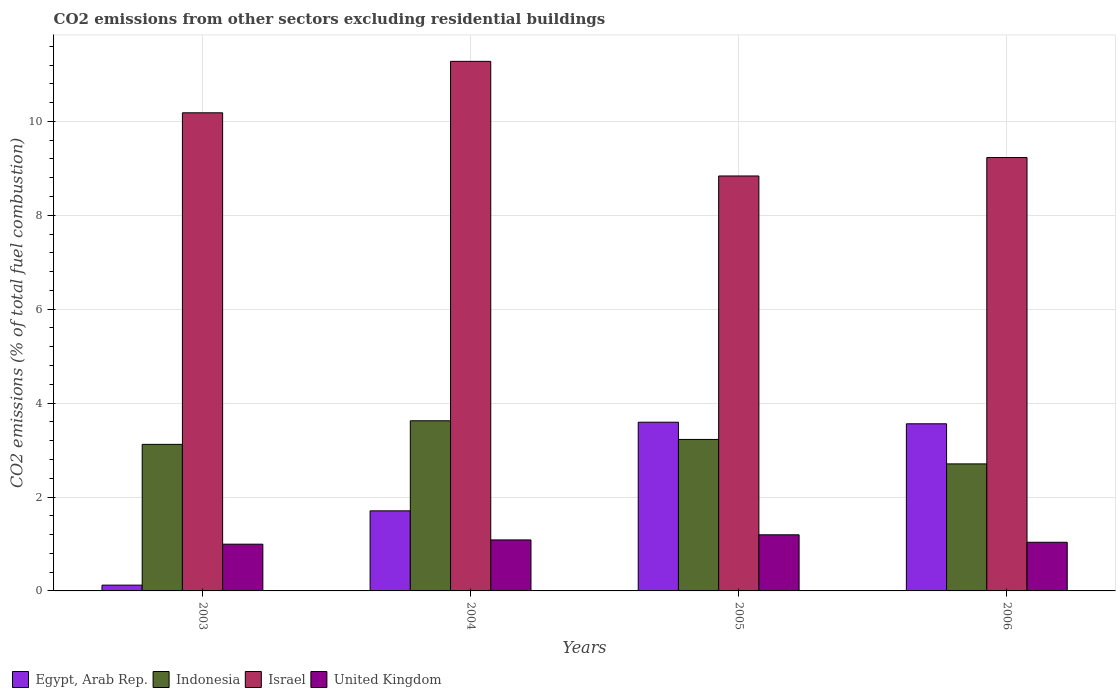How many different coloured bars are there?
Make the answer very short. 4. Are the number of bars per tick equal to the number of legend labels?
Give a very brief answer. Yes. What is the label of the 2nd group of bars from the left?
Your answer should be very brief. 2004. In how many cases, is the number of bars for a given year not equal to the number of legend labels?
Provide a succinct answer. 0. What is the total CO2 emitted in Indonesia in 2005?
Offer a terse response. 3.23. Across all years, what is the maximum total CO2 emitted in United Kingdom?
Your answer should be compact. 1.2. Across all years, what is the minimum total CO2 emitted in United Kingdom?
Your response must be concise. 1. In which year was the total CO2 emitted in Israel maximum?
Your answer should be compact. 2004. What is the total total CO2 emitted in United Kingdom in the graph?
Offer a terse response. 4.31. What is the difference between the total CO2 emitted in Egypt, Arab Rep. in 2004 and that in 2005?
Ensure brevity in your answer.  -1.89. What is the difference between the total CO2 emitted in Indonesia in 2005 and the total CO2 emitted in Egypt, Arab Rep. in 2006?
Keep it short and to the point. -0.33. What is the average total CO2 emitted in Egypt, Arab Rep. per year?
Make the answer very short. 2.25. In the year 2003, what is the difference between the total CO2 emitted in Israel and total CO2 emitted in Indonesia?
Your response must be concise. 7.06. What is the ratio of the total CO2 emitted in United Kingdom in 2005 to that in 2006?
Give a very brief answer. 1.15. Is the difference between the total CO2 emitted in Israel in 2005 and 2006 greater than the difference between the total CO2 emitted in Indonesia in 2005 and 2006?
Your answer should be compact. No. What is the difference between the highest and the second highest total CO2 emitted in Egypt, Arab Rep.?
Your answer should be compact. 0.03. What is the difference between the highest and the lowest total CO2 emitted in Egypt, Arab Rep.?
Offer a very short reply. 3.47. What does the 2nd bar from the right in 2003 represents?
Your response must be concise. Israel. Is it the case that in every year, the sum of the total CO2 emitted in Egypt, Arab Rep. and total CO2 emitted in Indonesia is greater than the total CO2 emitted in United Kingdom?
Your response must be concise. Yes. How many bars are there?
Your answer should be very brief. 16. How many years are there in the graph?
Your response must be concise. 4. Does the graph contain any zero values?
Make the answer very short. No. How are the legend labels stacked?
Provide a short and direct response. Horizontal. What is the title of the graph?
Offer a terse response. CO2 emissions from other sectors excluding residential buildings. What is the label or title of the Y-axis?
Ensure brevity in your answer.  CO2 emissions (% of total fuel combustion). What is the CO2 emissions (% of total fuel combustion) in Egypt, Arab Rep. in 2003?
Provide a succinct answer. 0.12. What is the CO2 emissions (% of total fuel combustion) of Indonesia in 2003?
Keep it short and to the point. 3.12. What is the CO2 emissions (% of total fuel combustion) of Israel in 2003?
Give a very brief answer. 10.18. What is the CO2 emissions (% of total fuel combustion) of United Kingdom in 2003?
Your answer should be very brief. 1. What is the CO2 emissions (% of total fuel combustion) of Egypt, Arab Rep. in 2004?
Offer a very short reply. 1.71. What is the CO2 emissions (% of total fuel combustion) of Indonesia in 2004?
Offer a terse response. 3.62. What is the CO2 emissions (% of total fuel combustion) of Israel in 2004?
Your answer should be compact. 11.28. What is the CO2 emissions (% of total fuel combustion) in United Kingdom in 2004?
Offer a terse response. 1.09. What is the CO2 emissions (% of total fuel combustion) of Egypt, Arab Rep. in 2005?
Offer a terse response. 3.59. What is the CO2 emissions (% of total fuel combustion) of Indonesia in 2005?
Your answer should be very brief. 3.23. What is the CO2 emissions (% of total fuel combustion) in Israel in 2005?
Ensure brevity in your answer.  8.84. What is the CO2 emissions (% of total fuel combustion) of United Kingdom in 2005?
Your answer should be very brief. 1.2. What is the CO2 emissions (% of total fuel combustion) of Egypt, Arab Rep. in 2006?
Ensure brevity in your answer.  3.56. What is the CO2 emissions (% of total fuel combustion) of Indonesia in 2006?
Your answer should be very brief. 2.71. What is the CO2 emissions (% of total fuel combustion) of Israel in 2006?
Offer a terse response. 9.23. What is the CO2 emissions (% of total fuel combustion) in United Kingdom in 2006?
Give a very brief answer. 1.04. Across all years, what is the maximum CO2 emissions (% of total fuel combustion) in Egypt, Arab Rep.?
Your answer should be very brief. 3.59. Across all years, what is the maximum CO2 emissions (% of total fuel combustion) of Indonesia?
Offer a very short reply. 3.62. Across all years, what is the maximum CO2 emissions (% of total fuel combustion) in Israel?
Provide a succinct answer. 11.28. Across all years, what is the maximum CO2 emissions (% of total fuel combustion) of United Kingdom?
Your answer should be compact. 1.2. Across all years, what is the minimum CO2 emissions (% of total fuel combustion) in Egypt, Arab Rep.?
Your answer should be compact. 0.12. Across all years, what is the minimum CO2 emissions (% of total fuel combustion) in Indonesia?
Give a very brief answer. 2.71. Across all years, what is the minimum CO2 emissions (% of total fuel combustion) in Israel?
Keep it short and to the point. 8.84. Across all years, what is the minimum CO2 emissions (% of total fuel combustion) in United Kingdom?
Provide a short and direct response. 1. What is the total CO2 emissions (% of total fuel combustion) of Egypt, Arab Rep. in the graph?
Keep it short and to the point. 8.98. What is the total CO2 emissions (% of total fuel combustion) in Indonesia in the graph?
Your answer should be very brief. 12.68. What is the total CO2 emissions (% of total fuel combustion) in Israel in the graph?
Your answer should be compact. 39.53. What is the total CO2 emissions (% of total fuel combustion) in United Kingdom in the graph?
Your answer should be very brief. 4.31. What is the difference between the CO2 emissions (% of total fuel combustion) in Egypt, Arab Rep. in 2003 and that in 2004?
Make the answer very short. -1.58. What is the difference between the CO2 emissions (% of total fuel combustion) in Indonesia in 2003 and that in 2004?
Keep it short and to the point. -0.5. What is the difference between the CO2 emissions (% of total fuel combustion) in Israel in 2003 and that in 2004?
Offer a terse response. -1.1. What is the difference between the CO2 emissions (% of total fuel combustion) in United Kingdom in 2003 and that in 2004?
Keep it short and to the point. -0.09. What is the difference between the CO2 emissions (% of total fuel combustion) of Egypt, Arab Rep. in 2003 and that in 2005?
Ensure brevity in your answer.  -3.47. What is the difference between the CO2 emissions (% of total fuel combustion) of Indonesia in 2003 and that in 2005?
Provide a succinct answer. -0.1. What is the difference between the CO2 emissions (% of total fuel combustion) of Israel in 2003 and that in 2005?
Make the answer very short. 1.35. What is the difference between the CO2 emissions (% of total fuel combustion) in United Kingdom in 2003 and that in 2005?
Offer a very short reply. -0.2. What is the difference between the CO2 emissions (% of total fuel combustion) of Egypt, Arab Rep. in 2003 and that in 2006?
Provide a short and direct response. -3.44. What is the difference between the CO2 emissions (% of total fuel combustion) of Indonesia in 2003 and that in 2006?
Ensure brevity in your answer.  0.42. What is the difference between the CO2 emissions (% of total fuel combustion) in Israel in 2003 and that in 2006?
Provide a succinct answer. 0.95. What is the difference between the CO2 emissions (% of total fuel combustion) of United Kingdom in 2003 and that in 2006?
Your answer should be very brief. -0.04. What is the difference between the CO2 emissions (% of total fuel combustion) of Egypt, Arab Rep. in 2004 and that in 2005?
Make the answer very short. -1.89. What is the difference between the CO2 emissions (% of total fuel combustion) in Indonesia in 2004 and that in 2005?
Keep it short and to the point. 0.4. What is the difference between the CO2 emissions (% of total fuel combustion) of Israel in 2004 and that in 2005?
Keep it short and to the point. 2.44. What is the difference between the CO2 emissions (% of total fuel combustion) in United Kingdom in 2004 and that in 2005?
Your response must be concise. -0.11. What is the difference between the CO2 emissions (% of total fuel combustion) in Egypt, Arab Rep. in 2004 and that in 2006?
Give a very brief answer. -1.85. What is the difference between the CO2 emissions (% of total fuel combustion) of Indonesia in 2004 and that in 2006?
Your answer should be compact. 0.92. What is the difference between the CO2 emissions (% of total fuel combustion) in Israel in 2004 and that in 2006?
Your answer should be compact. 2.05. What is the difference between the CO2 emissions (% of total fuel combustion) of United Kingdom in 2004 and that in 2006?
Make the answer very short. 0.05. What is the difference between the CO2 emissions (% of total fuel combustion) of Egypt, Arab Rep. in 2005 and that in 2006?
Your answer should be compact. 0.03. What is the difference between the CO2 emissions (% of total fuel combustion) of Indonesia in 2005 and that in 2006?
Keep it short and to the point. 0.52. What is the difference between the CO2 emissions (% of total fuel combustion) of Israel in 2005 and that in 2006?
Provide a succinct answer. -0.39. What is the difference between the CO2 emissions (% of total fuel combustion) in United Kingdom in 2005 and that in 2006?
Provide a succinct answer. 0.16. What is the difference between the CO2 emissions (% of total fuel combustion) of Egypt, Arab Rep. in 2003 and the CO2 emissions (% of total fuel combustion) of Indonesia in 2004?
Keep it short and to the point. -3.5. What is the difference between the CO2 emissions (% of total fuel combustion) in Egypt, Arab Rep. in 2003 and the CO2 emissions (% of total fuel combustion) in Israel in 2004?
Give a very brief answer. -11.16. What is the difference between the CO2 emissions (% of total fuel combustion) of Egypt, Arab Rep. in 2003 and the CO2 emissions (% of total fuel combustion) of United Kingdom in 2004?
Offer a terse response. -0.96. What is the difference between the CO2 emissions (% of total fuel combustion) of Indonesia in 2003 and the CO2 emissions (% of total fuel combustion) of Israel in 2004?
Ensure brevity in your answer.  -8.16. What is the difference between the CO2 emissions (% of total fuel combustion) in Indonesia in 2003 and the CO2 emissions (% of total fuel combustion) in United Kingdom in 2004?
Provide a short and direct response. 2.04. What is the difference between the CO2 emissions (% of total fuel combustion) in Israel in 2003 and the CO2 emissions (% of total fuel combustion) in United Kingdom in 2004?
Make the answer very short. 9.1. What is the difference between the CO2 emissions (% of total fuel combustion) of Egypt, Arab Rep. in 2003 and the CO2 emissions (% of total fuel combustion) of Indonesia in 2005?
Your answer should be compact. -3.1. What is the difference between the CO2 emissions (% of total fuel combustion) of Egypt, Arab Rep. in 2003 and the CO2 emissions (% of total fuel combustion) of Israel in 2005?
Provide a short and direct response. -8.71. What is the difference between the CO2 emissions (% of total fuel combustion) in Egypt, Arab Rep. in 2003 and the CO2 emissions (% of total fuel combustion) in United Kingdom in 2005?
Your answer should be compact. -1.07. What is the difference between the CO2 emissions (% of total fuel combustion) of Indonesia in 2003 and the CO2 emissions (% of total fuel combustion) of Israel in 2005?
Ensure brevity in your answer.  -5.72. What is the difference between the CO2 emissions (% of total fuel combustion) in Indonesia in 2003 and the CO2 emissions (% of total fuel combustion) in United Kingdom in 2005?
Offer a terse response. 1.93. What is the difference between the CO2 emissions (% of total fuel combustion) in Israel in 2003 and the CO2 emissions (% of total fuel combustion) in United Kingdom in 2005?
Ensure brevity in your answer.  8.99. What is the difference between the CO2 emissions (% of total fuel combustion) of Egypt, Arab Rep. in 2003 and the CO2 emissions (% of total fuel combustion) of Indonesia in 2006?
Offer a very short reply. -2.58. What is the difference between the CO2 emissions (% of total fuel combustion) in Egypt, Arab Rep. in 2003 and the CO2 emissions (% of total fuel combustion) in Israel in 2006?
Make the answer very short. -9.11. What is the difference between the CO2 emissions (% of total fuel combustion) of Egypt, Arab Rep. in 2003 and the CO2 emissions (% of total fuel combustion) of United Kingdom in 2006?
Provide a succinct answer. -0.91. What is the difference between the CO2 emissions (% of total fuel combustion) in Indonesia in 2003 and the CO2 emissions (% of total fuel combustion) in Israel in 2006?
Provide a short and direct response. -6.11. What is the difference between the CO2 emissions (% of total fuel combustion) of Indonesia in 2003 and the CO2 emissions (% of total fuel combustion) of United Kingdom in 2006?
Give a very brief answer. 2.09. What is the difference between the CO2 emissions (% of total fuel combustion) of Israel in 2003 and the CO2 emissions (% of total fuel combustion) of United Kingdom in 2006?
Your answer should be compact. 9.15. What is the difference between the CO2 emissions (% of total fuel combustion) in Egypt, Arab Rep. in 2004 and the CO2 emissions (% of total fuel combustion) in Indonesia in 2005?
Your answer should be very brief. -1.52. What is the difference between the CO2 emissions (% of total fuel combustion) of Egypt, Arab Rep. in 2004 and the CO2 emissions (% of total fuel combustion) of Israel in 2005?
Provide a succinct answer. -7.13. What is the difference between the CO2 emissions (% of total fuel combustion) in Egypt, Arab Rep. in 2004 and the CO2 emissions (% of total fuel combustion) in United Kingdom in 2005?
Ensure brevity in your answer.  0.51. What is the difference between the CO2 emissions (% of total fuel combustion) in Indonesia in 2004 and the CO2 emissions (% of total fuel combustion) in Israel in 2005?
Offer a very short reply. -5.21. What is the difference between the CO2 emissions (% of total fuel combustion) of Indonesia in 2004 and the CO2 emissions (% of total fuel combustion) of United Kingdom in 2005?
Provide a short and direct response. 2.43. What is the difference between the CO2 emissions (% of total fuel combustion) of Israel in 2004 and the CO2 emissions (% of total fuel combustion) of United Kingdom in 2005?
Give a very brief answer. 10.08. What is the difference between the CO2 emissions (% of total fuel combustion) in Egypt, Arab Rep. in 2004 and the CO2 emissions (% of total fuel combustion) in Indonesia in 2006?
Your response must be concise. -1. What is the difference between the CO2 emissions (% of total fuel combustion) of Egypt, Arab Rep. in 2004 and the CO2 emissions (% of total fuel combustion) of Israel in 2006?
Keep it short and to the point. -7.52. What is the difference between the CO2 emissions (% of total fuel combustion) of Egypt, Arab Rep. in 2004 and the CO2 emissions (% of total fuel combustion) of United Kingdom in 2006?
Offer a terse response. 0.67. What is the difference between the CO2 emissions (% of total fuel combustion) in Indonesia in 2004 and the CO2 emissions (% of total fuel combustion) in Israel in 2006?
Keep it short and to the point. -5.61. What is the difference between the CO2 emissions (% of total fuel combustion) of Indonesia in 2004 and the CO2 emissions (% of total fuel combustion) of United Kingdom in 2006?
Offer a very short reply. 2.59. What is the difference between the CO2 emissions (% of total fuel combustion) in Israel in 2004 and the CO2 emissions (% of total fuel combustion) in United Kingdom in 2006?
Make the answer very short. 10.24. What is the difference between the CO2 emissions (% of total fuel combustion) in Egypt, Arab Rep. in 2005 and the CO2 emissions (% of total fuel combustion) in Indonesia in 2006?
Ensure brevity in your answer.  0.89. What is the difference between the CO2 emissions (% of total fuel combustion) of Egypt, Arab Rep. in 2005 and the CO2 emissions (% of total fuel combustion) of Israel in 2006?
Your answer should be compact. -5.64. What is the difference between the CO2 emissions (% of total fuel combustion) in Egypt, Arab Rep. in 2005 and the CO2 emissions (% of total fuel combustion) in United Kingdom in 2006?
Provide a short and direct response. 2.56. What is the difference between the CO2 emissions (% of total fuel combustion) of Indonesia in 2005 and the CO2 emissions (% of total fuel combustion) of Israel in 2006?
Give a very brief answer. -6. What is the difference between the CO2 emissions (% of total fuel combustion) in Indonesia in 2005 and the CO2 emissions (% of total fuel combustion) in United Kingdom in 2006?
Your answer should be very brief. 2.19. What is the difference between the CO2 emissions (% of total fuel combustion) in Israel in 2005 and the CO2 emissions (% of total fuel combustion) in United Kingdom in 2006?
Provide a short and direct response. 7.8. What is the average CO2 emissions (% of total fuel combustion) in Egypt, Arab Rep. per year?
Your response must be concise. 2.25. What is the average CO2 emissions (% of total fuel combustion) of Indonesia per year?
Your answer should be very brief. 3.17. What is the average CO2 emissions (% of total fuel combustion) of Israel per year?
Your answer should be compact. 9.88. What is the average CO2 emissions (% of total fuel combustion) of United Kingdom per year?
Offer a terse response. 1.08. In the year 2003, what is the difference between the CO2 emissions (% of total fuel combustion) in Egypt, Arab Rep. and CO2 emissions (% of total fuel combustion) in Indonesia?
Your answer should be compact. -3. In the year 2003, what is the difference between the CO2 emissions (% of total fuel combustion) of Egypt, Arab Rep. and CO2 emissions (% of total fuel combustion) of Israel?
Offer a terse response. -10.06. In the year 2003, what is the difference between the CO2 emissions (% of total fuel combustion) of Egypt, Arab Rep. and CO2 emissions (% of total fuel combustion) of United Kingdom?
Your answer should be very brief. -0.87. In the year 2003, what is the difference between the CO2 emissions (% of total fuel combustion) of Indonesia and CO2 emissions (% of total fuel combustion) of Israel?
Ensure brevity in your answer.  -7.06. In the year 2003, what is the difference between the CO2 emissions (% of total fuel combustion) in Indonesia and CO2 emissions (% of total fuel combustion) in United Kingdom?
Keep it short and to the point. 2.13. In the year 2003, what is the difference between the CO2 emissions (% of total fuel combustion) of Israel and CO2 emissions (% of total fuel combustion) of United Kingdom?
Your response must be concise. 9.19. In the year 2004, what is the difference between the CO2 emissions (% of total fuel combustion) in Egypt, Arab Rep. and CO2 emissions (% of total fuel combustion) in Indonesia?
Your answer should be very brief. -1.92. In the year 2004, what is the difference between the CO2 emissions (% of total fuel combustion) of Egypt, Arab Rep. and CO2 emissions (% of total fuel combustion) of Israel?
Provide a short and direct response. -9.57. In the year 2004, what is the difference between the CO2 emissions (% of total fuel combustion) in Egypt, Arab Rep. and CO2 emissions (% of total fuel combustion) in United Kingdom?
Make the answer very short. 0.62. In the year 2004, what is the difference between the CO2 emissions (% of total fuel combustion) in Indonesia and CO2 emissions (% of total fuel combustion) in Israel?
Provide a short and direct response. -7.65. In the year 2004, what is the difference between the CO2 emissions (% of total fuel combustion) in Indonesia and CO2 emissions (% of total fuel combustion) in United Kingdom?
Your response must be concise. 2.54. In the year 2004, what is the difference between the CO2 emissions (% of total fuel combustion) in Israel and CO2 emissions (% of total fuel combustion) in United Kingdom?
Provide a short and direct response. 10.19. In the year 2005, what is the difference between the CO2 emissions (% of total fuel combustion) of Egypt, Arab Rep. and CO2 emissions (% of total fuel combustion) of Indonesia?
Make the answer very short. 0.37. In the year 2005, what is the difference between the CO2 emissions (% of total fuel combustion) of Egypt, Arab Rep. and CO2 emissions (% of total fuel combustion) of Israel?
Your answer should be compact. -5.24. In the year 2005, what is the difference between the CO2 emissions (% of total fuel combustion) of Egypt, Arab Rep. and CO2 emissions (% of total fuel combustion) of United Kingdom?
Provide a short and direct response. 2.4. In the year 2005, what is the difference between the CO2 emissions (% of total fuel combustion) of Indonesia and CO2 emissions (% of total fuel combustion) of Israel?
Give a very brief answer. -5.61. In the year 2005, what is the difference between the CO2 emissions (% of total fuel combustion) of Indonesia and CO2 emissions (% of total fuel combustion) of United Kingdom?
Keep it short and to the point. 2.03. In the year 2005, what is the difference between the CO2 emissions (% of total fuel combustion) of Israel and CO2 emissions (% of total fuel combustion) of United Kingdom?
Give a very brief answer. 7.64. In the year 2006, what is the difference between the CO2 emissions (% of total fuel combustion) of Egypt, Arab Rep. and CO2 emissions (% of total fuel combustion) of Indonesia?
Offer a very short reply. 0.85. In the year 2006, what is the difference between the CO2 emissions (% of total fuel combustion) of Egypt, Arab Rep. and CO2 emissions (% of total fuel combustion) of Israel?
Offer a very short reply. -5.67. In the year 2006, what is the difference between the CO2 emissions (% of total fuel combustion) of Egypt, Arab Rep. and CO2 emissions (% of total fuel combustion) of United Kingdom?
Give a very brief answer. 2.52. In the year 2006, what is the difference between the CO2 emissions (% of total fuel combustion) of Indonesia and CO2 emissions (% of total fuel combustion) of Israel?
Keep it short and to the point. -6.53. In the year 2006, what is the difference between the CO2 emissions (% of total fuel combustion) in Indonesia and CO2 emissions (% of total fuel combustion) in United Kingdom?
Your response must be concise. 1.67. In the year 2006, what is the difference between the CO2 emissions (% of total fuel combustion) of Israel and CO2 emissions (% of total fuel combustion) of United Kingdom?
Your answer should be very brief. 8.19. What is the ratio of the CO2 emissions (% of total fuel combustion) in Egypt, Arab Rep. in 2003 to that in 2004?
Your response must be concise. 0.07. What is the ratio of the CO2 emissions (% of total fuel combustion) of Indonesia in 2003 to that in 2004?
Your answer should be very brief. 0.86. What is the ratio of the CO2 emissions (% of total fuel combustion) of Israel in 2003 to that in 2004?
Provide a short and direct response. 0.9. What is the ratio of the CO2 emissions (% of total fuel combustion) of United Kingdom in 2003 to that in 2004?
Provide a short and direct response. 0.92. What is the ratio of the CO2 emissions (% of total fuel combustion) in Egypt, Arab Rep. in 2003 to that in 2005?
Your answer should be compact. 0.03. What is the ratio of the CO2 emissions (% of total fuel combustion) of Indonesia in 2003 to that in 2005?
Give a very brief answer. 0.97. What is the ratio of the CO2 emissions (% of total fuel combustion) of Israel in 2003 to that in 2005?
Offer a terse response. 1.15. What is the ratio of the CO2 emissions (% of total fuel combustion) in United Kingdom in 2003 to that in 2005?
Your answer should be compact. 0.83. What is the ratio of the CO2 emissions (% of total fuel combustion) of Egypt, Arab Rep. in 2003 to that in 2006?
Ensure brevity in your answer.  0.03. What is the ratio of the CO2 emissions (% of total fuel combustion) in Indonesia in 2003 to that in 2006?
Give a very brief answer. 1.15. What is the ratio of the CO2 emissions (% of total fuel combustion) in Israel in 2003 to that in 2006?
Provide a succinct answer. 1.1. What is the ratio of the CO2 emissions (% of total fuel combustion) in United Kingdom in 2003 to that in 2006?
Your answer should be compact. 0.96. What is the ratio of the CO2 emissions (% of total fuel combustion) of Egypt, Arab Rep. in 2004 to that in 2005?
Your answer should be very brief. 0.47. What is the ratio of the CO2 emissions (% of total fuel combustion) in Indonesia in 2004 to that in 2005?
Make the answer very short. 1.12. What is the ratio of the CO2 emissions (% of total fuel combustion) of Israel in 2004 to that in 2005?
Give a very brief answer. 1.28. What is the ratio of the CO2 emissions (% of total fuel combustion) in United Kingdom in 2004 to that in 2005?
Offer a terse response. 0.91. What is the ratio of the CO2 emissions (% of total fuel combustion) in Egypt, Arab Rep. in 2004 to that in 2006?
Your answer should be compact. 0.48. What is the ratio of the CO2 emissions (% of total fuel combustion) in Indonesia in 2004 to that in 2006?
Your response must be concise. 1.34. What is the ratio of the CO2 emissions (% of total fuel combustion) of Israel in 2004 to that in 2006?
Your answer should be very brief. 1.22. What is the ratio of the CO2 emissions (% of total fuel combustion) of United Kingdom in 2004 to that in 2006?
Ensure brevity in your answer.  1.05. What is the ratio of the CO2 emissions (% of total fuel combustion) of Egypt, Arab Rep. in 2005 to that in 2006?
Give a very brief answer. 1.01. What is the ratio of the CO2 emissions (% of total fuel combustion) of Indonesia in 2005 to that in 2006?
Ensure brevity in your answer.  1.19. What is the ratio of the CO2 emissions (% of total fuel combustion) in Israel in 2005 to that in 2006?
Keep it short and to the point. 0.96. What is the ratio of the CO2 emissions (% of total fuel combustion) in United Kingdom in 2005 to that in 2006?
Provide a succinct answer. 1.15. What is the difference between the highest and the second highest CO2 emissions (% of total fuel combustion) of Egypt, Arab Rep.?
Make the answer very short. 0.03. What is the difference between the highest and the second highest CO2 emissions (% of total fuel combustion) of Indonesia?
Give a very brief answer. 0.4. What is the difference between the highest and the second highest CO2 emissions (% of total fuel combustion) in Israel?
Provide a succinct answer. 1.1. What is the difference between the highest and the second highest CO2 emissions (% of total fuel combustion) in United Kingdom?
Your answer should be compact. 0.11. What is the difference between the highest and the lowest CO2 emissions (% of total fuel combustion) in Egypt, Arab Rep.?
Your answer should be compact. 3.47. What is the difference between the highest and the lowest CO2 emissions (% of total fuel combustion) of Indonesia?
Your response must be concise. 0.92. What is the difference between the highest and the lowest CO2 emissions (% of total fuel combustion) of Israel?
Provide a succinct answer. 2.44. What is the difference between the highest and the lowest CO2 emissions (% of total fuel combustion) of United Kingdom?
Your answer should be compact. 0.2. 